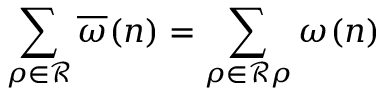<formula> <loc_0><loc_0><loc_500><loc_500>\sum _ { \rho \in \mathcal { R } } \overline { \omega } ( \boldsymbol n ) = \sum _ { \rho \in \mathcal { R } \rho } \omega ( \boldsymbol n )</formula> 